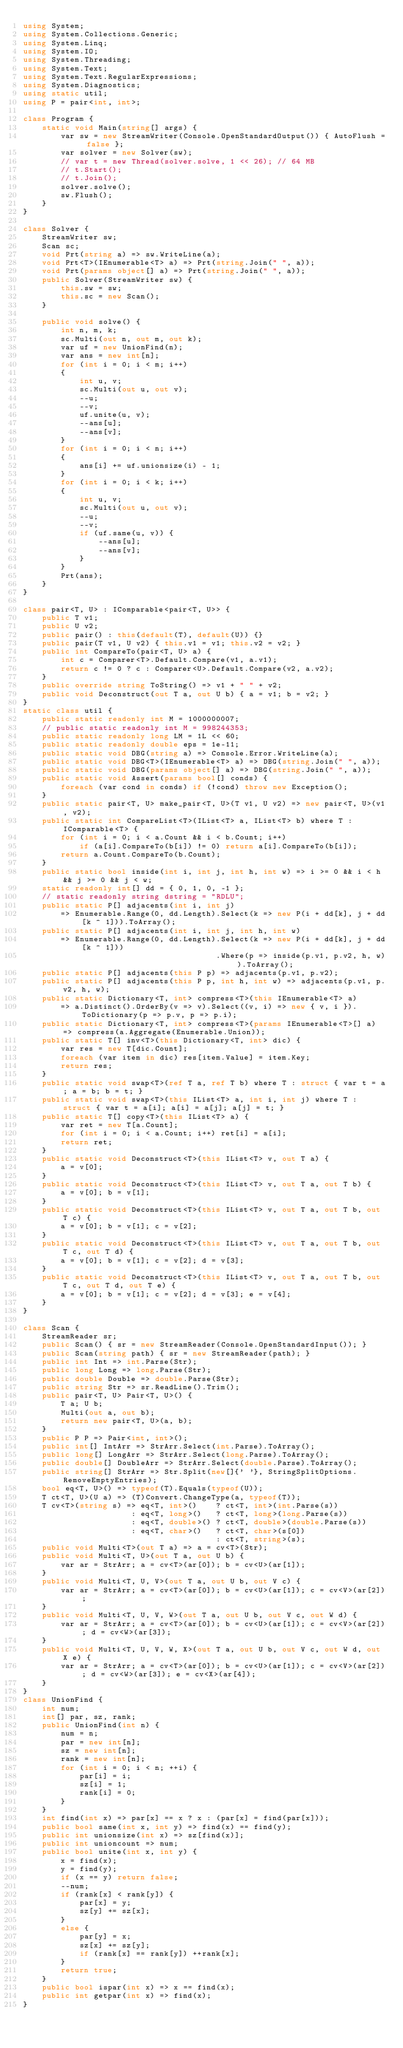Convert code to text. <code><loc_0><loc_0><loc_500><loc_500><_C#_>using System;
using System.Collections.Generic;
using System.Linq;
using System.IO;
using System.Threading;
using System.Text;
using System.Text.RegularExpressions;
using System.Diagnostics;
using static util;
using P = pair<int, int>;

class Program {
    static void Main(string[] args) {
        var sw = new StreamWriter(Console.OpenStandardOutput()) { AutoFlush = false };
        var solver = new Solver(sw);
        // var t = new Thread(solver.solve, 1 << 26); // 64 MB
        // t.Start();
        // t.Join();
        solver.solve();
        sw.Flush();
    }
}

class Solver {
    StreamWriter sw;
    Scan sc;
    void Prt(string a) => sw.WriteLine(a);
    void Prt<T>(IEnumerable<T> a) => Prt(string.Join(" ", a));
    void Prt(params object[] a) => Prt(string.Join(" ", a));
    public Solver(StreamWriter sw) {
        this.sw = sw;
        this.sc = new Scan();
    }

    public void solve() {
        int n, m, k;
        sc.Multi(out n, out m, out k);
        var uf = new UnionFind(n);
        var ans = new int[n];
        for (int i = 0; i < m; i++)
        {
            int u, v;
            sc.Multi(out u, out v);
            --u;
            --v;
            uf.unite(u, v);
            --ans[u];
            --ans[v];
        }
        for (int i = 0; i < n; i++)
        {
            ans[i] += uf.unionsize(i) - 1;
        }
        for (int i = 0; i < k; i++)
        {
            int u, v;
            sc.Multi(out u, out v);
            --u;
            --v;
            if (uf.same(u, v)) {
                --ans[u];
                --ans[v];
            }
        }
        Prt(ans);
    }
}

class pair<T, U> : IComparable<pair<T, U>> {
    public T v1;
    public U v2;
    public pair() : this(default(T), default(U)) {}
    public pair(T v1, U v2) { this.v1 = v1; this.v2 = v2; }
    public int CompareTo(pair<T, U> a) {
        int c = Comparer<T>.Default.Compare(v1, a.v1);
        return c != 0 ? c : Comparer<U>.Default.Compare(v2, a.v2);
    }
    public override string ToString() => v1 + " " + v2;
    public void Deconstruct(out T a, out U b) { a = v1; b = v2; }
}
static class util {
    public static readonly int M = 1000000007;
    // public static readonly int M = 998244353;
    public static readonly long LM = 1L << 60;
    public static readonly double eps = 1e-11;
    public static void DBG(string a) => Console.Error.WriteLine(a);
    public static void DBG<T>(IEnumerable<T> a) => DBG(string.Join(" ", a));
    public static void DBG(params object[] a) => DBG(string.Join(" ", a));
    public static void Assert(params bool[] conds) {
        foreach (var cond in conds) if (!cond) throw new Exception();
    }
    public static pair<T, U> make_pair<T, U>(T v1, U v2) => new pair<T, U>(v1, v2);
    public static int CompareList<T>(IList<T> a, IList<T> b) where T : IComparable<T> {
        for (int i = 0; i < a.Count && i < b.Count; i++)
            if (a[i].CompareTo(b[i]) != 0) return a[i].CompareTo(b[i]);
        return a.Count.CompareTo(b.Count);
    }
    public static bool inside(int i, int j, int h, int w) => i >= 0 && i < h && j >= 0 && j < w;
    static readonly int[] dd = { 0, 1, 0, -1 };
    // static readonly string dstring = "RDLU";
    public static P[] adjacents(int i, int j)
        => Enumerable.Range(0, dd.Length).Select(k => new P(i + dd[k], j + dd[k ^ 1])).ToArray();
    public static P[] adjacents(int i, int j, int h, int w)
        => Enumerable.Range(0, dd.Length).Select(k => new P(i + dd[k], j + dd[k ^ 1]))
                                         .Where(p => inside(p.v1, p.v2, h, w)).ToArray();
    public static P[] adjacents(this P p) => adjacents(p.v1, p.v2);
    public static P[] adjacents(this P p, int h, int w) => adjacents(p.v1, p.v2, h, w);
    public static Dictionary<T, int> compress<T>(this IEnumerable<T> a)
        => a.Distinct().OrderBy(v => v).Select((v, i) => new { v, i }).ToDictionary(p => p.v, p => p.i);
    public static Dictionary<T, int> compress<T>(params IEnumerable<T>[] a) => compress(a.Aggregate(Enumerable.Union));
    public static T[] inv<T>(this Dictionary<T, int> dic) {
        var res = new T[dic.Count];
        foreach (var item in dic) res[item.Value] = item.Key;
        return res;
    }
    public static void swap<T>(ref T a, ref T b) where T : struct { var t = a; a = b; b = t; }
    public static void swap<T>(this IList<T> a, int i, int j) where T : struct { var t = a[i]; a[i] = a[j]; a[j] = t; }
    public static T[] copy<T>(this IList<T> a) {
        var ret = new T[a.Count];
        for (int i = 0; i < a.Count; i++) ret[i] = a[i];
        return ret;
    }
    public static void Deconstruct<T>(this IList<T> v, out T a) {
        a = v[0];
    }
    public static void Deconstruct<T>(this IList<T> v, out T a, out T b) {
        a = v[0]; b = v[1];
    }
    public static void Deconstruct<T>(this IList<T> v, out T a, out T b, out T c) {
        a = v[0]; b = v[1]; c = v[2];
    }
    public static void Deconstruct<T>(this IList<T> v, out T a, out T b, out T c, out T d) {
        a = v[0]; b = v[1]; c = v[2]; d = v[3];
    }
    public static void Deconstruct<T>(this IList<T> v, out T a, out T b, out T c, out T d, out T e) {
        a = v[0]; b = v[1]; c = v[2]; d = v[3]; e = v[4];
    }
}

class Scan {
    StreamReader sr;
    public Scan() { sr = new StreamReader(Console.OpenStandardInput()); }
    public Scan(string path) { sr = new StreamReader(path); }
    public int Int => int.Parse(Str);
    public long Long => long.Parse(Str);
    public double Double => double.Parse(Str);
    public string Str => sr.ReadLine().Trim();
    public pair<T, U> Pair<T, U>() {
        T a; U b;
        Multi(out a, out b);
        return new pair<T, U>(a, b);
    }
    public P P => Pair<int, int>();
    public int[] IntArr => StrArr.Select(int.Parse).ToArray();
    public long[] LongArr => StrArr.Select(long.Parse).ToArray();
    public double[] DoubleArr => StrArr.Select(double.Parse).ToArray();
    public string[] StrArr => Str.Split(new[]{' '}, StringSplitOptions.RemoveEmptyEntries);
    bool eq<T, U>() => typeof(T).Equals(typeof(U));
    T ct<T, U>(U a) => (T)Convert.ChangeType(a, typeof(T));
    T cv<T>(string s) => eq<T, int>()    ? ct<T, int>(int.Parse(s))
                       : eq<T, long>()   ? ct<T, long>(long.Parse(s))
                       : eq<T, double>() ? ct<T, double>(double.Parse(s))
                       : eq<T, char>()   ? ct<T, char>(s[0])
                                         : ct<T, string>(s);
    public void Multi<T>(out T a) => a = cv<T>(Str);
    public void Multi<T, U>(out T a, out U b) {
        var ar = StrArr; a = cv<T>(ar[0]); b = cv<U>(ar[1]);
    }
    public void Multi<T, U, V>(out T a, out U b, out V c) {
        var ar = StrArr; a = cv<T>(ar[0]); b = cv<U>(ar[1]); c = cv<V>(ar[2]);
    }
    public void Multi<T, U, V, W>(out T a, out U b, out V c, out W d) {
        var ar = StrArr; a = cv<T>(ar[0]); b = cv<U>(ar[1]); c = cv<V>(ar[2]); d = cv<W>(ar[3]);
    }
    public void Multi<T, U, V, W, X>(out T a, out U b, out V c, out W d, out X e) {
        var ar = StrArr; a = cv<T>(ar[0]); b = cv<U>(ar[1]); c = cv<V>(ar[2]); d = cv<W>(ar[3]); e = cv<X>(ar[4]);
    }
}
class UnionFind {
    int num;
    int[] par, sz, rank;
    public UnionFind(int n) {
        num = n;
        par = new int[n];
        sz = new int[n];
        rank = new int[n];
        for (int i = 0; i < n; ++i) {
            par[i] = i;
            sz[i] = 1;
            rank[i] = 0;
        }
    }
    int find(int x) => par[x] == x ? x : (par[x] = find(par[x]));
    public bool same(int x, int y) => find(x) == find(y);
    public int unionsize(int x) => sz[find(x)];
    public int unioncount => num;
    public bool unite(int x, int y) {
        x = find(x);
        y = find(y);
        if (x == y) return false;
        --num;
        if (rank[x] < rank[y]) {
            par[x] = y;
            sz[y] += sz[x];
        }
        else {
            par[y] = x;
            sz[x] += sz[y];
            if (rank[x] == rank[y]) ++rank[x];
        }
        return true;
    }
    public bool ispar(int x) => x == find(x);
    public int getpar(int x) => find(x);
}
</code> 